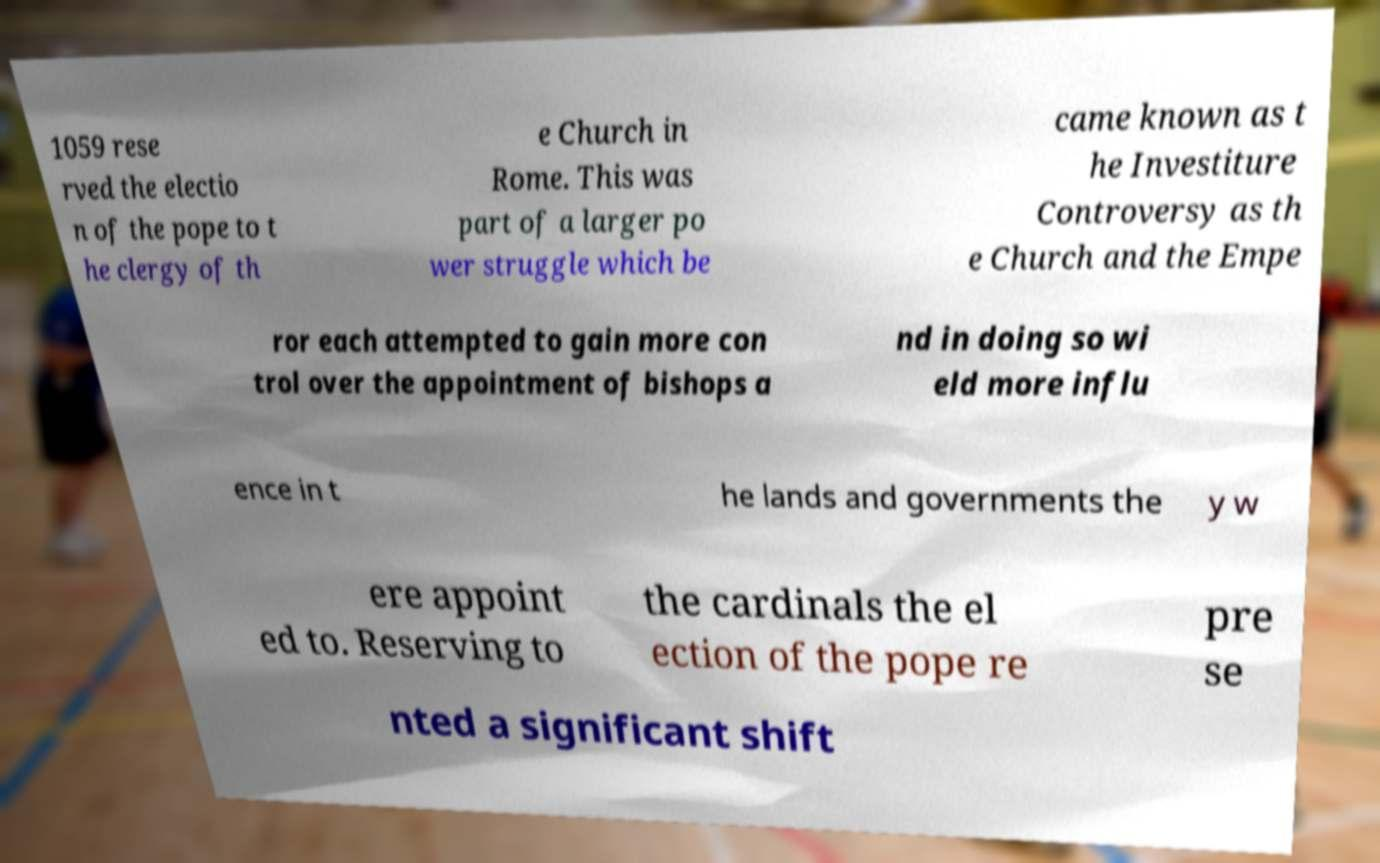Please identify and transcribe the text found in this image. 1059 rese rved the electio n of the pope to t he clergy of th e Church in Rome. This was part of a larger po wer struggle which be came known as t he Investiture Controversy as th e Church and the Empe ror each attempted to gain more con trol over the appointment of bishops a nd in doing so wi eld more influ ence in t he lands and governments the y w ere appoint ed to. Reserving to the cardinals the el ection of the pope re pre se nted a significant shift 